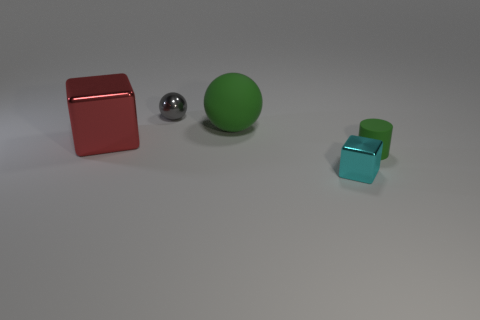Do these objects serve a purpose or represent something? The objects in the image seem to be placed there to display a variety of geometric forms and materials. The red metal cube, the shiny metal sphere, and the green rubber ball each have different textures and colors, demonstrating how light interacts with various surfaces. The transparent blue cubes might represent fragility or delicacy due to their transparency and color. This arrangement could be used for educational purposes, perhaps in a physics or art class, to study properties of light, materials, and shapes. 